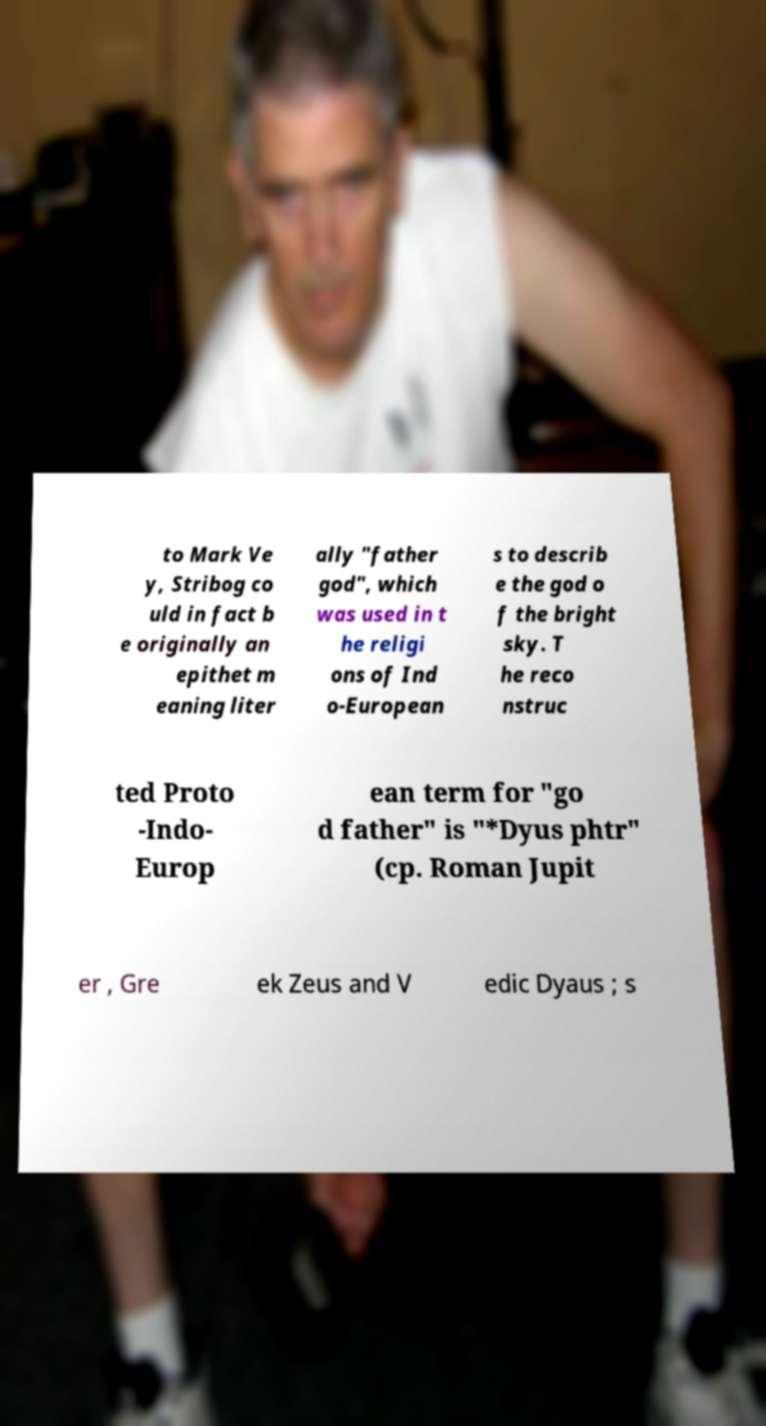What messages or text are displayed in this image? I need them in a readable, typed format. to Mark Ve y, Stribog co uld in fact b e originally an epithet m eaning liter ally "father god", which was used in t he religi ons of Ind o-European s to describ e the god o f the bright sky. T he reco nstruc ted Proto -Indo- Europ ean term for "go d father" is "*Dyus phtr" (cp. Roman Jupit er , Gre ek Zeus and V edic Dyaus ; s 